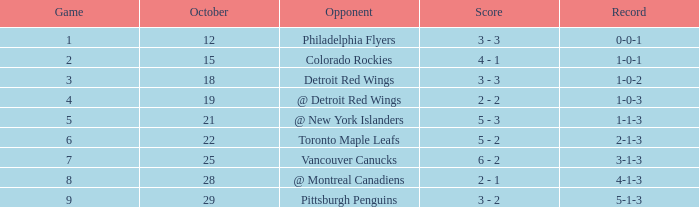Name the most october for game less than 1 None. 